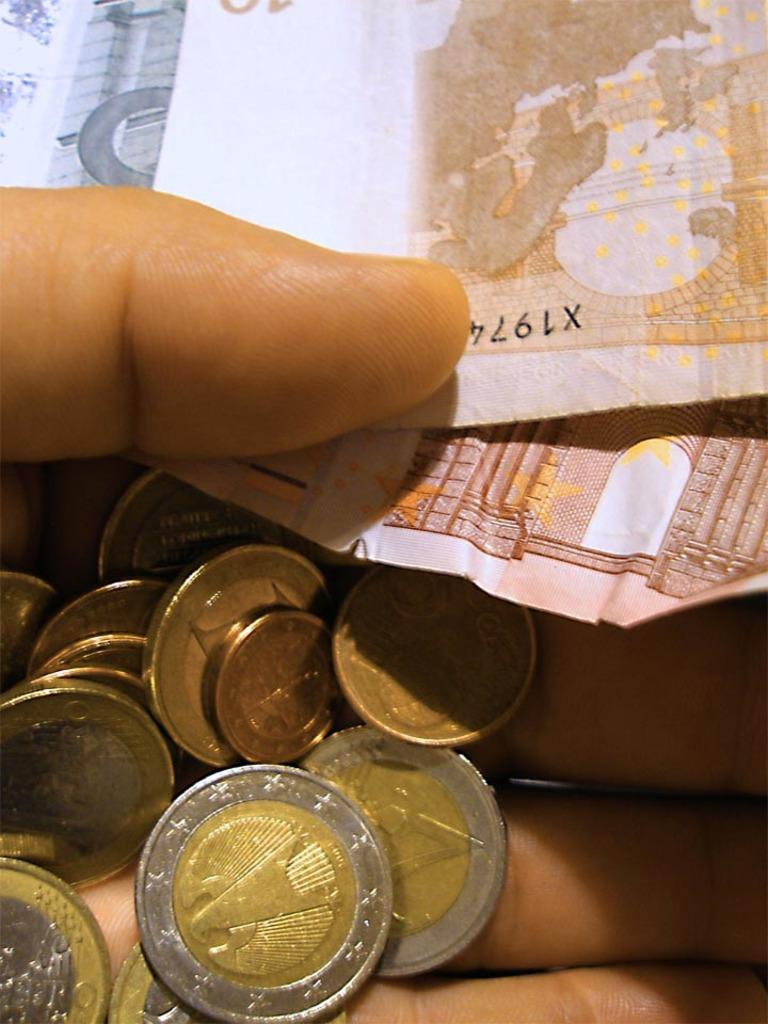<image>
Summarize the visual content of the image. A hand is holding various coins and some bills, the top one having a serial number starting with X1974. 